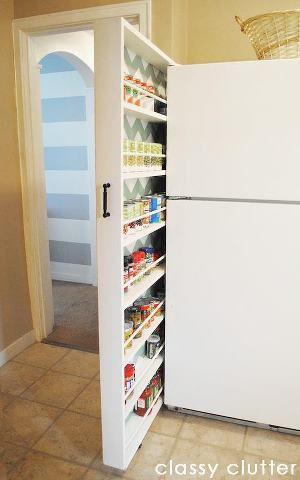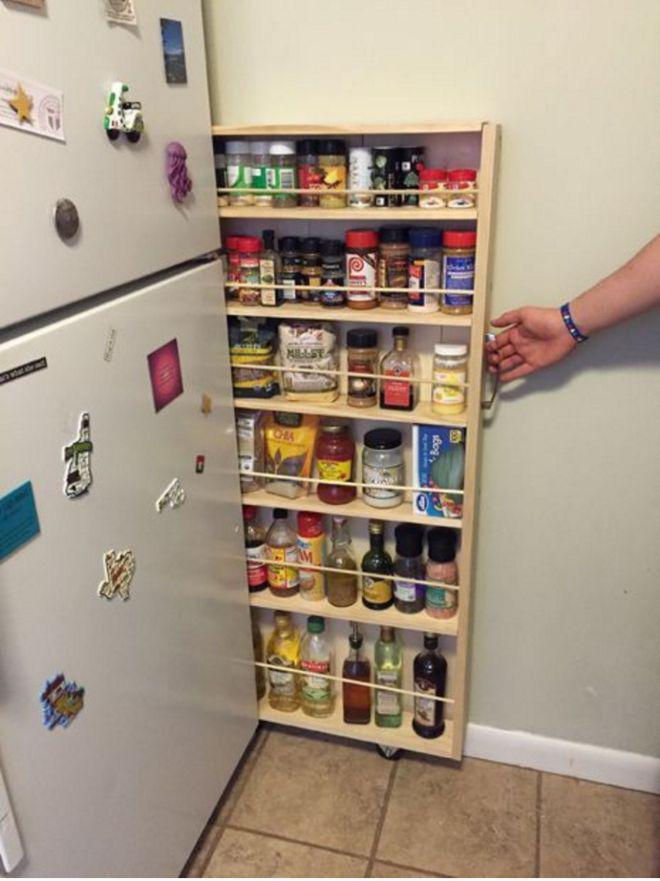The first image is the image on the left, the second image is the image on the right. Evaluate the accuracy of this statement regarding the images: "A narrow white pantry with filled shelves is extended out alongside a white refrigerator with no magnets on it, in the left image.". Is it true? Answer yes or no. Yes. The first image is the image on the left, the second image is the image on the right. Evaluate the accuracy of this statement regarding the images: "At least one shelving unit is used as behind the fridge pantry space.". Is it true? Answer yes or no. Yes. 